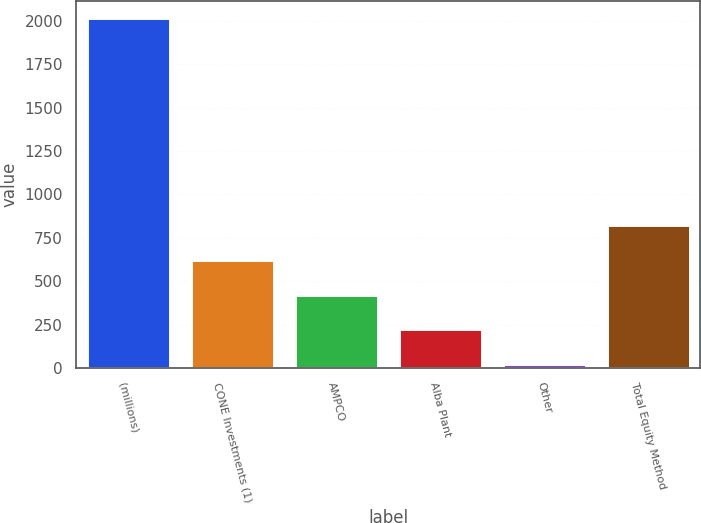<chart> <loc_0><loc_0><loc_500><loc_500><bar_chart><fcel>(millions)<fcel>CONE Investments (1)<fcel>AMPCO<fcel>Alba Plant<fcel>Other<fcel>Total Equity Method<nl><fcel>2016<fcel>623<fcel>424<fcel>225<fcel>26<fcel>822<nl></chart> 